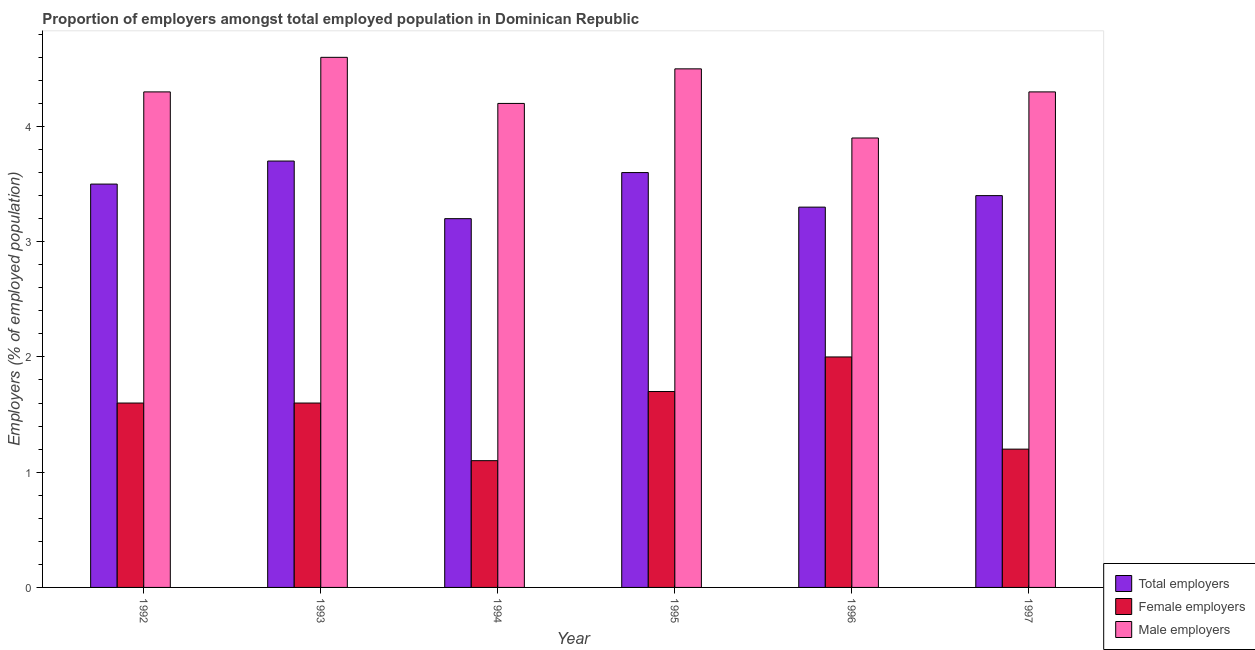Are the number of bars per tick equal to the number of legend labels?
Provide a short and direct response. Yes. How many bars are there on the 1st tick from the left?
Keep it short and to the point. 3. How many bars are there on the 5th tick from the right?
Your answer should be very brief. 3. In how many cases, is the number of bars for a given year not equal to the number of legend labels?
Give a very brief answer. 0. What is the percentage of total employers in 1994?
Offer a very short reply. 3.2. Across all years, what is the maximum percentage of total employers?
Provide a succinct answer. 3.7. Across all years, what is the minimum percentage of female employers?
Your response must be concise. 1.1. In which year was the percentage of male employers minimum?
Offer a terse response. 1996. What is the total percentage of total employers in the graph?
Provide a succinct answer. 20.7. What is the difference between the percentage of male employers in 1995 and that in 1997?
Ensure brevity in your answer.  0.2. What is the difference between the percentage of female employers in 1994 and the percentage of male employers in 1995?
Your response must be concise. -0.6. What is the average percentage of total employers per year?
Provide a short and direct response. 3.45. What is the ratio of the percentage of male employers in 1992 to that in 1994?
Offer a very short reply. 1.02. What is the difference between the highest and the second highest percentage of male employers?
Ensure brevity in your answer.  0.1. In how many years, is the percentage of male employers greater than the average percentage of male employers taken over all years?
Keep it short and to the point. 4. Is the sum of the percentage of female employers in 1994 and 1996 greater than the maximum percentage of male employers across all years?
Provide a short and direct response. Yes. What does the 1st bar from the left in 1992 represents?
Your answer should be very brief. Total employers. What does the 3rd bar from the right in 1994 represents?
Offer a terse response. Total employers. How many bars are there?
Provide a succinct answer. 18. How many years are there in the graph?
Make the answer very short. 6. What is the difference between two consecutive major ticks on the Y-axis?
Provide a succinct answer. 1. Does the graph contain grids?
Provide a succinct answer. No. Where does the legend appear in the graph?
Give a very brief answer. Bottom right. How are the legend labels stacked?
Give a very brief answer. Vertical. What is the title of the graph?
Offer a terse response. Proportion of employers amongst total employed population in Dominican Republic. What is the label or title of the X-axis?
Give a very brief answer. Year. What is the label or title of the Y-axis?
Provide a succinct answer. Employers (% of employed population). What is the Employers (% of employed population) in Female employers in 1992?
Give a very brief answer. 1.6. What is the Employers (% of employed population) in Male employers in 1992?
Provide a succinct answer. 4.3. What is the Employers (% of employed population) in Total employers in 1993?
Offer a very short reply. 3.7. What is the Employers (% of employed population) in Female employers in 1993?
Ensure brevity in your answer.  1.6. What is the Employers (% of employed population) in Male employers in 1993?
Keep it short and to the point. 4.6. What is the Employers (% of employed population) of Total employers in 1994?
Provide a short and direct response. 3.2. What is the Employers (% of employed population) in Female employers in 1994?
Ensure brevity in your answer.  1.1. What is the Employers (% of employed population) of Male employers in 1994?
Offer a terse response. 4.2. What is the Employers (% of employed population) of Total employers in 1995?
Your response must be concise. 3.6. What is the Employers (% of employed population) of Female employers in 1995?
Give a very brief answer. 1.7. What is the Employers (% of employed population) in Total employers in 1996?
Keep it short and to the point. 3.3. What is the Employers (% of employed population) in Male employers in 1996?
Provide a short and direct response. 3.9. What is the Employers (% of employed population) in Total employers in 1997?
Your response must be concise. 3.4. What is the Employers (% of employed population) in Female employers in 1997?
Your response must be concise. 1.2. What is the Employers (% of employed population) in Male employers in 1997?
Provide a short and direct response. 4.3. Across all years, what is the maximum Employers (% of employed population) in Total employers?
Keep it short and to the point. 3.7. Across all years, what is the maximum Employers (% of employed population) in Male employers?
Offer a terse response. 4.6. Across all years, what is the minimum Employers (% of employed population) in Total employers?
Make the answer very short. 3.2. Across all years, what is the minimum Employers (% of employed population) in Female employers?
Offer a very short reply. 1.1. Across all years, what is the minimum Employers (% of employed population) in Male employers?
Provide a succinct answer. 3.9. What is the total Employers (% of employed population) in Total employers in the graph?
Ensure brevity in your answer.  20.7. What is the total Employers (% of employed population) in Female employers in the graph?
Provide a succinct answer. 9.2. What is the total Employers (% of employed population) of Male employers in the graph?
Your response must be concise. 25.8. What is the difference between the Employers (% of employed population) of Total employers in 1992 and that in 1993?
Your answer should be very brief. -0.2. What is the difference between the Employers (% of employed population) in Male employers in 1992 and that in 1993?
Ensure brevity in your answer.  -0.3. What is the difference between the Employers (% of employed population) of Male employers in 1992 and that in 1994?
Offer a very short reply. 0.1. What is the difference between the Employers (% of employed population) in Total employers in 1992 and that in 1995?
Give a very brief answer. -0.1. What is the difference between the Employers (% of employed population) in Total employers in 1992 and that in 1996?
Offer a terse response. 0.2. What is the difference between the Employers (% of employed population) of Total employers in 1993 and that in 1995?
Make the answer very short. 0.1. What is the difference between the Employers (% of employed population) in Female employers in 1993 and that in 1995?
Provide a succinct answer. -0.1. What is the difference between the Employers (% of employed population) of Male employers in 1993 and that in 1996?
Provide a succinct answer. 0.7. What is the difference between the Employers (% of employed population) of Female employers in 1993 and that in 1997?
Provide a short and direct response. 0.4. What is the difference between the Employers (% of employed population) in Male employers in 1993 and that in 1997?
Your answer should be compact. 0.3. What is the difference between the Employers (% of employed population) of Female employers in 1994 and that in 1995?
Offer a terse response. -0.6. What is the difference between the Employers (% of employed population) of Total employers in 1994 and that in 1997?
Provide a short and direct response. -0.2. What is the difference between the Employers (% of employed population) in Female employers in 1995 and that in 1996?
Provide a short and direct response. -0.3. What is the difference between the Employers (% of employed population) of Male employers in 1995 and that in 1996?
Provide a succinct answer. 0.6. What is the difference between the Employers (% of employed population) in Total employers in 1995 and that in 1997?
Offer a terse response. 0.2. What is the difference between the Employers (% of employed population) in Male employers in 1995 and that in 1997?
Offer a very short reply. 0.2. What is the difference between the Employers (% of employed population) of Total employers in 1996 and that in 1997?
Offer a terse response. -0.1. What is the difference between the Employers (% of employed population) of Male employers in 1996 and that in 1997?
Provide a short and direct response. -0.4. What is the difference between the Employers (% of employed population) of Total employers in 1992 and the Employers (% of employed population) of Male employers in 1993?
Your answer should be compact. -1.1. What is the difference between the Employers (% of employed population) of Female employers in 1992 and the Employers (% of employed population) of Male employers in 1993?
Provide a short and direct response. -3. What is the difference between the Employers (% of employed population) in Total employers in 1992 and the Employers (% of employed population) in Female employers in 1994?
Your answer should be compact. 2.4. What is the difference between the Employers (% of employed population) of Total employers in 1992 and the Employers (% of employed population) of Male employers in 1994?
Offer a very short reply. -0.7. What is the difference between the Employers (% of employed population) of Female employers in 1992 and the Employers (% of employed population) of Male employers in 1995?
Ensure brevity in your answer.  -2.9. What is the difference between the Employers (% of employed population) of Total employers in 1992 and the Employers (% of employed population) of Female employers in 1996?
Provide a succinct answer. 1.5. What is the difference between the Employers (% of employed population) of Female employers in 1992 and the Employers (% of employed population) of Male employers in 1996?
Offer a very short reply. -2.3. What is the difference between the Employers (% of employed population) in Total employers in 1992 and the Employers (% of employed population) in Female employers in 1997?
Ensure brevity in your answer.  2.3. What is the difference between the Employers (% of employed population) in Total employers in 1992 and the Employers (% of employed population) in Male employers in 1997?
Give a very brief answer. -0.8. What is the difference between the Employers (% of employed population) of Total employers in 1993 and the Employers (% of employed population) of Male employers in 1995?
Your response must be concise. -0.8. What is the difference between the Employers (% of employed population) in Female employers in 1993 and the Employers (% of employed population) in Male employers in 1995?
Your answer should be very brief. -2.9. What is the difference between the Employers (% of employed population) of Total employers in 1993 and the Employers (% of employed population) of Female employers in 1996?
Keep it short and to the point. 1.7. What is the difference between the Employers (% of employed population) in Female employers in 1993 and the Employers (% of employed population) in Male employers in 1996?
Your answer should be very brief. -2.3. What is the difference between the Employers (% of employed population) in Female employers in 1993 and the Employers (% of employed population) in Male employers in 1997?
Your response must be concise. -2.7. What is the difference between the Employers (% of employed population) in Total employers in 1994 and the Employers (% of employed population) in Female employers in 1995?
Provide a short and direct response. 1.5. What is the difference between the Employers (% of employed population) in Total employers in 1994 and the Employers (% of employed population) in Male employers in 1995?
Your response must be concise. -1.3. What is the difference between the Employers (% of employed population) in Total employers in 1995 and the Employers (% of employed population) in Female employers in 1996?
Keep it short and to the point. 1.6. What is the difference between the Employers (% of employed population) of Total employers in 1995 and the Employers (% of employed population) of Female employers in 1997?
Keep it short and to the point. 2.4. What is the average Employers (% of employed population) in Total employers per year?
Offer a very short reply. 3.45. What is the average Employers (% of employed population) of Female employers per year?
Offer a terse response. 1.53. In the year 1992, what is the difference between the Employers (% of employed population) in Total employers and Employers (% of employed population) in Female employers?
Your answer should be compact. 1.9. In the year 1992, what is the difference between the Employers (% of employed population) in Total employers and Employers (% of employed population) in Male employers?
Provide a succinct answer. -0.8. In the year 1993, what is the difference between the Employers (% of employed population) of Total employers and Employers (% of employed population) of Male employers?
Offer a very short reply. -0.9. In the year 1993, what is the difference between the Employers (% of employed population) of Female employers and Employers (% of employed population) of Male employers?
Make the answer very short. -3. In the year 1994, what is the difference between the Employers (% of employed population) of Total employers and Employers (% of employed population) of Female employers?
Provide a short and direct response. 2.1. In the year 1994, what is the difference between the Employers (% of employed population) in Total employers and Employers (% of employed population) in Male employers?
Keep it short and to the point. -1. In the year 1994, what is the difference between the Employers (% of employed population) in Female employers and Employers (% of employed population) in Male employers?
Make the answer very short. -3.1. In the year 1995, what is the difference between the Employers (% of employed population) in Total employers and Employers (% of employed population) in Male employers?
Your answer should be very brief. -0.9. In the year 1995, what is the difference between the Employers (% of employed population) of Female employers and Employers (% of employed population) of Male employers?
Provide a short and direct response. -2.8. In the year 1997, what is the difference between the Employers (% of employed population) of Total employers and Employers (% of employed population) of Male employers?
Provide a succinct answer. -0.9. What is the ratio of the Employers (% of employed population) of Total employers in 1992 to that in 1993?
Make the answer very short. 0.95. What is the ratio of the Employers (% of employed population) of Male employers in 1992 to that in 1993?
Make the answer very short. 0.93. What is the ratio of the Employers (% of employed population) of Total employers in 1992 to that in 1994?
Offer a terse response. 1.09. What is the ratio of the Employers (% of employed population) of Female employers in 1992 to that in 1994?
Make the answer very short. 1.45. What is the ratio of the Employers (% of employed population) of Male employers in 1992 to that in 1994?
Give a very brief answer. 1.02. What is the ratio of the Employers (% of employed population) of Total employers in 1992 to that in 1995?
Make the answer very short. 0.97. What is the ratio of the Employers (% of employed population) of Female employers in 1992 to that in 1995?
Your response must be concise. 0.94. What is the ratio of the Employers (% of employed population) of Male employers in 1992 to that in 1995?
Offer a terse response. 0.96. What is the ratio of the Employers (% of employed population) in Total employers in 1992 to that in 1996?
Make the answer very short. 1.06. What is the ratio of the Employers (% of employed population) in Female employers in 1992 to that in 1996?
Offer a terse response. 0.8. What is the ratio of the Employers (% of employed population) of Male employers in 1992 to that in 1996?
Ensure brevity in your answer.  1.1. What is the ratio of the Employers (% of employed population) of Total employers in 1992 to that in 1997?
Offer a terse response. 1.03. What is the ratio of the Employers (% of employed population) in Female employers in 1992 to that in 1997?
Your answer should be very brief. 1.33. What is the ratio of the Employers (% of employed population) of Total employers in 1993 to that in 1994?
Your answer should be very brief. 1.16. What is the ratio of the Employers (% of employed population) of Female employers in 1993 to that in 1994?
Your response must be concise. 1.45. What is the ratio of the Employers (% of employed population) of Male employers in 1993 to that in 1994?
Ensure brevity in your answer.  1.1. What is the ratio of the Employers (% of employed population) of Total employers in 1993 to that in 1995?
Your answer should be very brief. 1.03. What is the ratio of the Employers (% of employed population) of Female employers in 1993 to that in 1995?
Provide a short and direct response. 0.94. What is the ratio of the Employers (% of employed population) in Male employers in 1993 to that in 1995?
Provide a succinct answer. 1.02. What is the ratio of the Employers (% of employed population) in Total employers in 1993 to that in 1996?
Provide a short and direct response. 1.12. What is the ratio of the Employers (% of employed population) of Female employers in 1993 to that in 1996?
Your answer should be compact. 0.8. What is the ratio of the Employers (% of employed population) of Male employers in 1993 to that in 1996?
Provide a short and direct response. 1.18. What is the ratio of the Employers (% of employed population) in Total employers in 1993 to that in 1997?
Offer a very short reply. 1.09. What is the ratio of the Employers (% of employed population) of Female employers in 1993 to that in 1997?
Offer a terse response. 1.33. What is the ratio of the Employers (% of employed population) in Male employers in 1993 to that in 1997?
Your response must be concise. 1.07. What is the ratio of the Employers (% of employed population) of Total employers in 1994 to that in 1995?
Make the answer very short. 0.89. What is the ratio of the Employers (% of employed population) of Female employers in 1994 to that in 1995?
Make the answer very short. 0.65. What is the ratio of the Employers (% of employed population) of Total employers in 1994 to that in 1996?
Offer a very short reply. 0.97. What is the ratio of the Employers (% of employed population) of Female employers in 1994 to that in 1996?
Your response must be concise. 0.55. What is the ratio of the Employers (% of employed population) in Total employers in 1994 to that in 1997?
Offer a terse response. 0.94. What is the ratio of the Employers (% of employed population) of Male employers in 1994 to that in 1997?
Your answer should be very brief. 0.98. What is the ratio of the Employers (% of employed population) of Male employers in 1995 to that in 1996?
Give a very brief answer. 1.15. What is the ratio of the Employers (% of employed population) in Total employers in 1995 to that in 1997?
Keep it short and to the point. 1.06. What is the ratio of the Employers (% of employed population) in Female employers in 1995 to that in 1997?
Provide a short and direct response. 1.42. What is the ratio of the Employers (% of employed population) in Male employers in 1995 to that in 1997?
Your answer should be compact. 1.05. What is the ratio of the Employers (% of employed population) in Total employers in 1996 to that in 1997?
Keep it short and to the point. 0.97. What is the ratio of the Employers (% of employed population) of Male employers in 1996 to that in 1997?
Provide a succinct answer. 0.91. What is the difference between the highest and the second highest Employers (% of employed population) in Female employers?
Provide a succinct answer. 0.3. What is the difference between the highest and the second highest Employers (% of employed population) in Male employers?
Your answer should be compact. 0.1. What is the difference between the highest and the lowest Employers (% of employed population) of Total employers?
Your response must be concise. 0.5. What is the difference between the highest and the lowest Employers (% of employed population) of Male employers?
Keep it short and to the point. 0.7. 